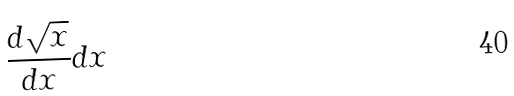Convert formula to latex. <formula><loc_0><loc_0><loc_500><loc_500>\frac { d \sqrt { x } } { d x } d x</formula> 